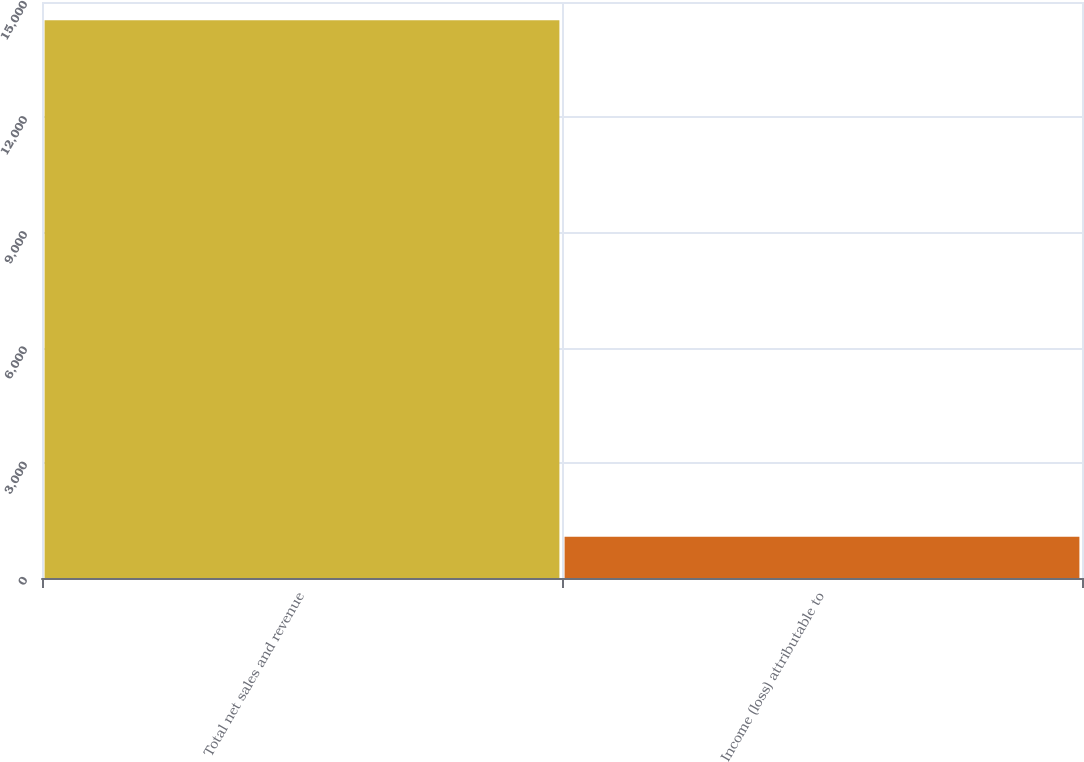Convert chart to OTSL. <chart><loc_0><loc_0><loc_500><loc_500><bar_chart><fcel>Total net sales and revenue<fcel>Income (loss) attributable to<nl><fcel>14522<fcel>1076<nl></chart> 